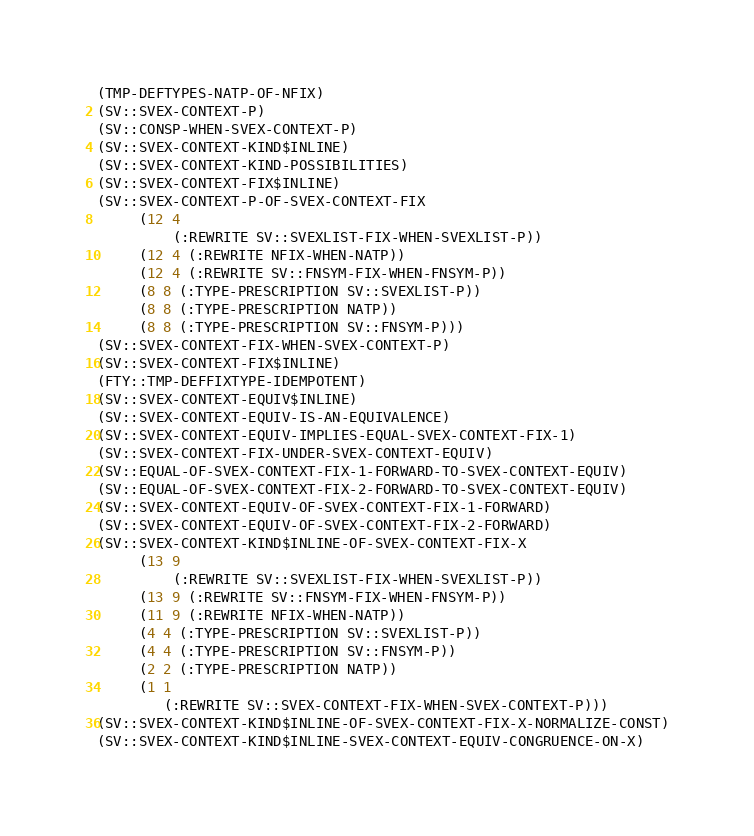<code> <loc_0><loc_0><loc_500><loc_500><_Lisp_>(TMP-DEFTYPES-NATP-OF-NFIX)
(SV::SVEX-CONTEXT-P)
(SV::CONSP-WHEN-SVEX-CONTEXT-P)
(SV::SVEX-CONTEXT-KIND$INLINE)
(SV::SVEX-CONTEXT-KIND-POSSIBILITIES)
(SV::SVEX-CONTEXT-FIX$INLINE)
(SV::SVEX-CONTEXT-P-OF-SVEX-CONTEXT-FIX
     (12 4
         (:REWRITE SV::SVEXLIST-FIX-WHEN-SVEXLIST-P))
     (12 4 (:REWRITE NFIX-WHEN-NATP))
     (12 4 (:REWRITE SV::FNSYM-FIX-WHEN-FNSYM-P))
     (8 8 (:TYPE-PRESCRIPTION SV::SVEXLIST-P))
     (8 8 (:TYPE-PRESCRIPTION NATP))
     (8 8 (:TYPE-PRESCRIPTION SV::FNSYM-P)))
(SV::SVEX-CONTEXT-FIX-WHEN-SVEX-CONTEXT-P)
(SV::SVEX-CONTEXT-FIX$INLINE)
(FTY::TMP-DEFFIXTYPE-IDEMPOTENT)
(SV::SVEX-CONTEXT-EQUIV$INLINE)
(SV::SVEX-CONTEXT-EQUIV-IS-AN-EQUIVALENCE)
(SV::SVEX-CONTEXT-EQUIV-IMPLIES-EQUAL-SVEX-CONTEXT-FIX-1)
(SV::SVEX-CONTEXT-FIX-UNDER-SVEX-CONTEXT-EQUIV)
(SV::EQUAL-OF-SVEX-CONTEXT-FIX-1-FORWARD-TO-SVEX-CONTEXT-EQUIV)
(SV::EQUAL-OF-SVEX-CONTEXT-FIX-2-FORWARD-TO-SVEX-CONTEXT-EQUIV)
(SV::SVEX-CONTEXT-EQUIV-OF-SVEX-CONTEXT-FIX-1-FORWARD)
(SV::SVEX-CONTEXT-EQUIV-OF-SVEX-CONTEXT-FIX-2-FORWARD)
(SV::SVEX-CONTEXT-KIND$INLINE-OF-SVEX-CONTEXT-FIX-X
     (13 9
         (:REWRITE SV::SVEXLIST-FIX-WHEN-SVEXLIST-P))
     (13 9 (:REWRITE SV::FNSYM-FIX-WHEN-FNSYM-P))
     (11 9 (:REWRITE NFIX-WHEN-NATP))
     (4 4 (:TYPE-PRESCRIPTION SV::SVEXLIST-P))
     (4 4 (:TYPE-PRESCRIPTION SV::FNSYM-P))
     (2 2 (:TYPE-PRESCRIPTION NATP))
     (1 1
        (:REWRITE SV::SVEX-CONTEXT-FIX-WHEN-SVEX-CONTEXT-P)))
(SV::SVEX-CONTEXT-KIND$INLINE-OF-SVEX-CONTEXT-FIX-X-NORMALIZE-CONST)
(SV::SVEX-CONTEXT-KIND$INLINE-SVEX-CONTEXT-EQUIV-CONGRUENCE-ON-X)</code> 